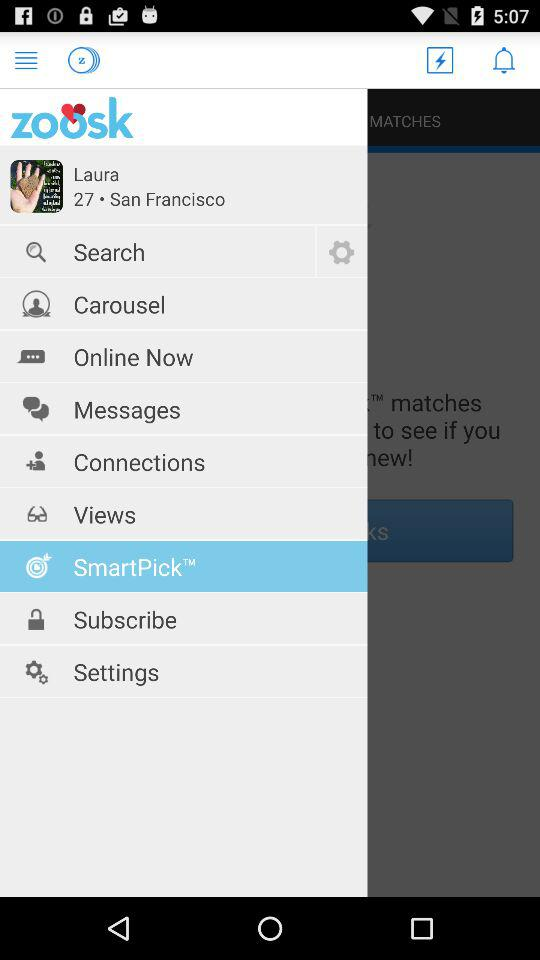What is the app name? The app name is "zoosk". 